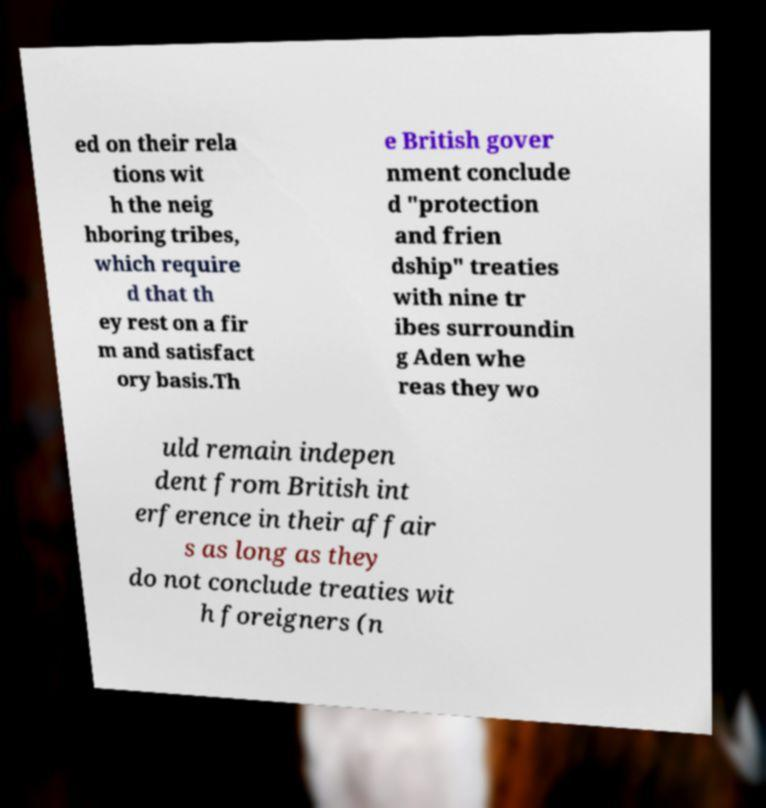Please identify and transcribe the text found in this image. ed on their rela tions wit h the neig hboring tribes, which require d that th ey rest on a fir m and satisfact ory basis.Th e British gover nment conclude d "protection and frien dship" treaties with nine tr ibes surroundin g Aden whe reas they wo uld remain indepen dent from British int erference in their affair s as long as they do not conclude treaties wit h foreigners (n 